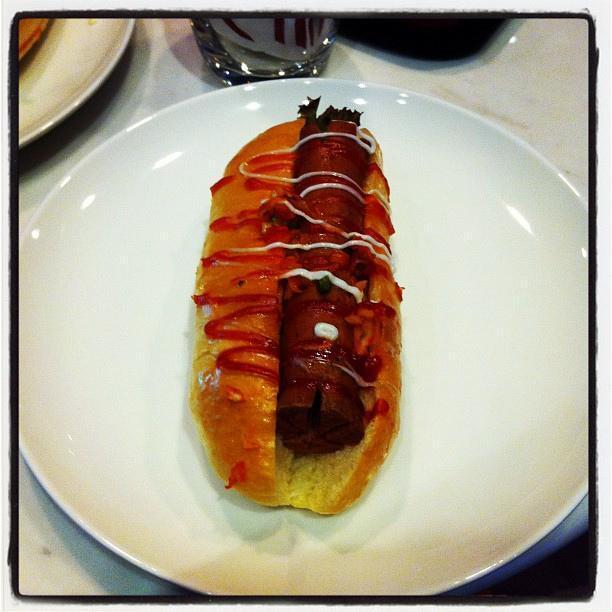How many people are holding umbrellas in the photo?
Give a very brief answer. 0. 